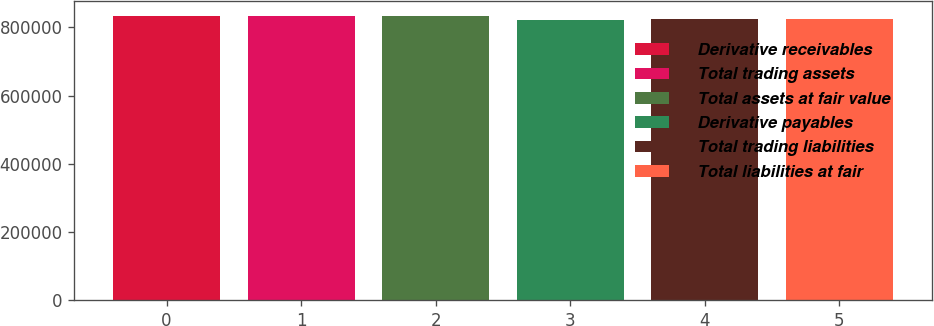Convert chart. <chart><loc_0><loc_0><loc_500><loc_500><bar_chart><fcel>Derivative receivables<fcel>Total trading assets<fcel>Total assets at fair value<fcel>Derivative payables<fcel>Total trading liabilities<fcel>Total liabilities at fair<nl><fcel>832731<fcel>833758<fcel>834786<fcel>822458<fcel>823485<fcel>824513<nl></chart> 